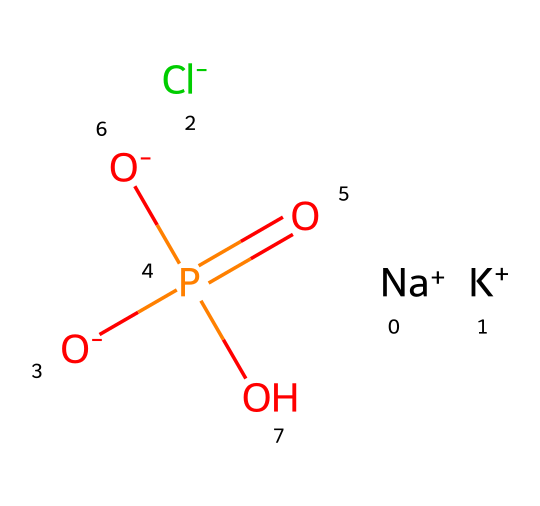What ions are present in this ionic liquid structure? The SMILES representation shows sodium (Na+), potassium (K+), chloride (Cl-), and a phosphate ion (O- P(=O)([O-])O). All these ions contribute to the ionic nature of the liquid.
Answer: sodium, potassium, chloride, phosphate How many total atoms are in this ionic liquid? To find the total number of atoms, count each type of atom in the SMILES representation: 2 Na, 2 K, 4 O, 1 P, and 1 Cl, resulting in a total of 10 atoms.
Answer: 10 What type of bond is primarily present in ionic liquids like this one? Ionic liquids primarily consist of ionic bonds formed between positively charged ions (cations) and negatively charged ions (anions) as depicted in the SMILES structure.
Answer: ionic What is the significance of the phosphate group in the electrolyte formulation? The phosphate group acts as a stabilizing agent in the electrolyte formulation, providing necessary ionic strength and facilitating better conductivity in sports drinks.
Answer: stabilizing agent How many different types of cations are present in this ionic liquid structure? There are two distinct cations in the structure: sodium (Na+) and potassium (K+). Each is a different type and contributes to the overall ionic character.
Answer: 2 